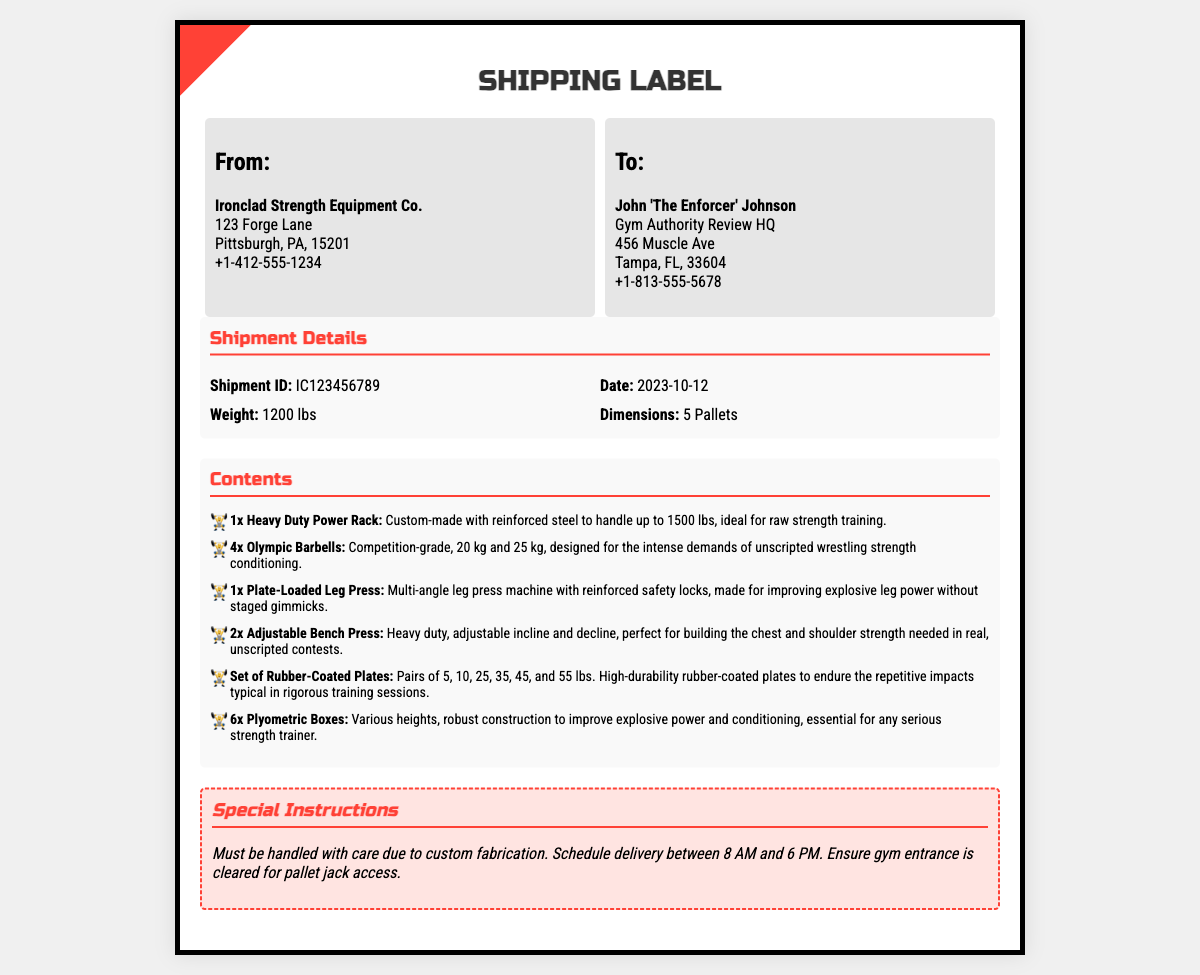What is the name of the sender? The sender's name is indicated at the top of the label as Ironclad Strength Equipment Co.
Answer: Ironclad Strength Equipment Co What is the shipment ID? The shipment ID is a unique identifier presented in the shipment details section.
Answer: IC123456789 What is today’s date? Today's date is provided in the shipment details section as the date of shipment.
Answer: 2023-10-12 How much does the shipment weigh? The weight of the shipment is specified in the shipment details section.
Answer: 1200 lbs What is the size of the shipment? The dimensions of the shipment is mentioned in the shipment details section.
Answer: 5 Pallets Who is the recipient? The recipient's name is noted in the shipping address section under "To:".
Answer: John 'The Enforcer' Johnson What type of gym equipment is included in the shipment? The contents section lists various types of gym equipment included in this shipment.
Answer: Custom-made gym equipment What special instructions are provided for the shipment? The special instructions section details how the shipment should be handled.
Answer: Must be handled with care due to custom fabrication How many Olympic barbells are included? The shipment's contents list how many Olympic barbells are included.
Answer: 4x 